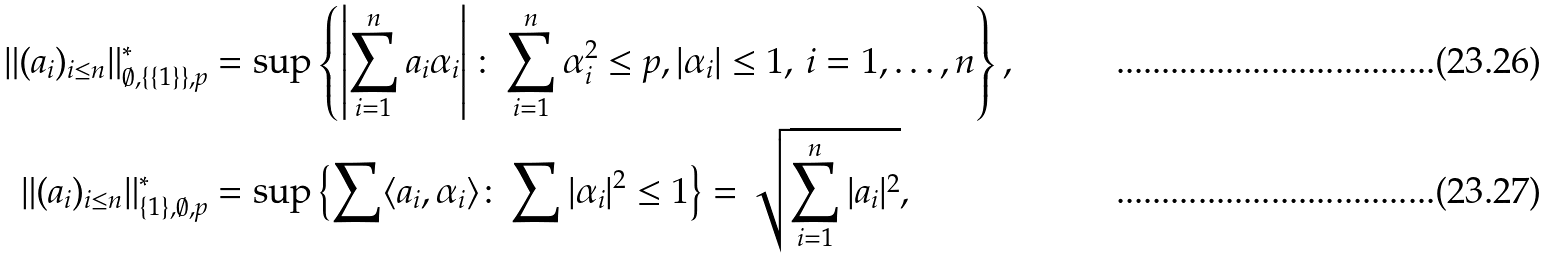<formula> <loc_0><loc_0><loc_500><loc_500>\| ( a _ { i } ) _ { i \leq n } \| ^ { \ast } _ { \emptyset , \{ \{ 1 \} \} , p } & = \sup \left \{ \left | \sum _ { i = 1 } ^ { n } a _ { i } \alpha _ { i } \right | \colon \sum _ { i = 1 } ^ { n } \alpha _ { i } ^ { 2 } \leq p , | \alpha _ { i } | \leq 1 , \, i = 1 , \dots , n \right \} , \\ \| ( a _ { i } ) _ { i \leq n } \| ^ { \ast } _ { \{ 1 \} , \emptyset , p } & = \sup \left \{ \sum \langle a _ { i } , \alpha _ { i } \rangle \colon \sum | \alpha _ { i } | ^ { 2 } \leq 1 \right \} = \sqrt { \sum _ { i = 1 } ^ { n } | a _ { i } | ^ { 2 } } ,</formula> 